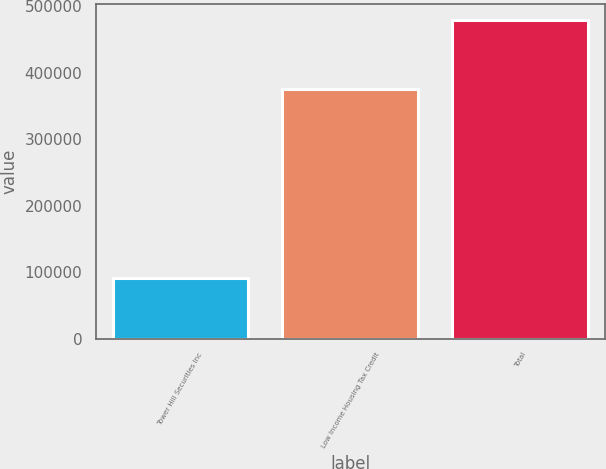Convert chart to OTSL. <chart><loc_0><loc_0><loc_500><loc_500><bar_chart><fcel>Tower Hill Securities Inc<fcel>Low Income Housing Tax Credit<fcel>Total<nl><fcel>90514<fcel>376098<fcel>479989<nl></chart> 